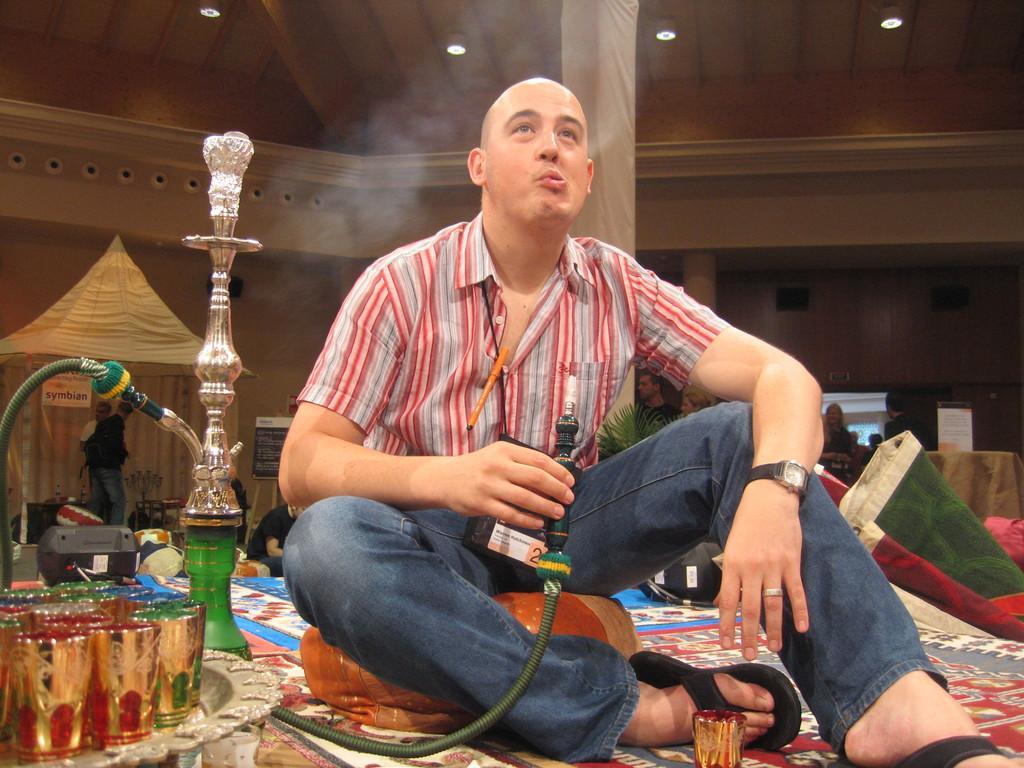In one or two sentences, can you explain what this image depicts? In the image in the center, we can see one person sitting and holding a hookah pipe. On the left side of the image, we can see one hookah pot and one table. On the table, we can see few glasses. In the background there is a wall, roof, pillar, carpet, tent, banners, lights, few people and a few other objects. 